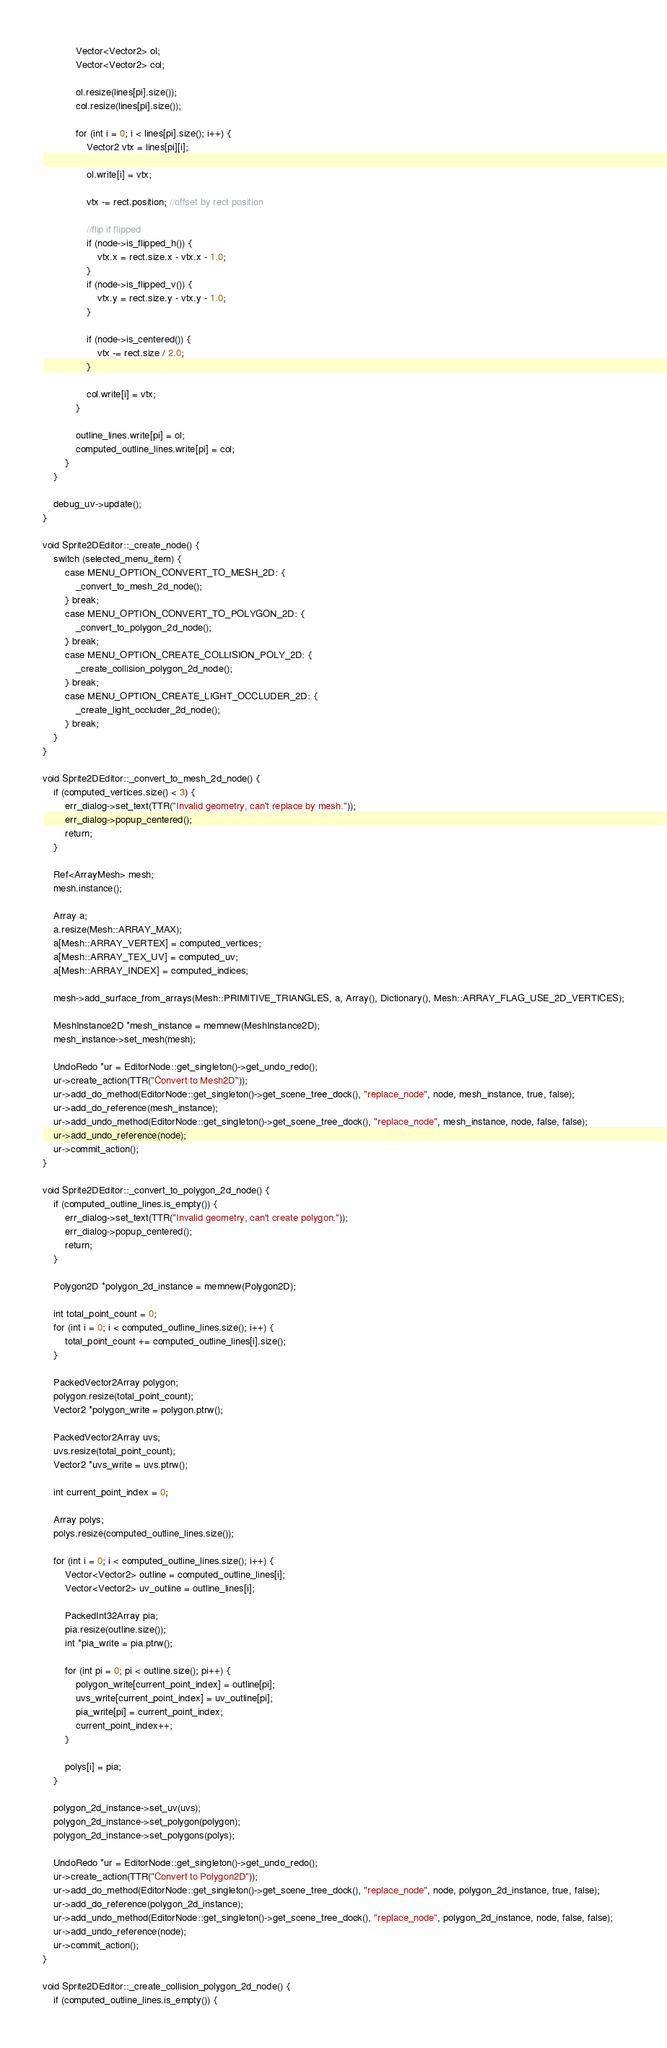<code> <loc_0><loc_0><loc_500><loc_500><_C++_>			Vector<Vector2> ol;
			Vector<Vector2> col;

			ol.resize(lines[pi].size());
			col.resize(lines[pi].size());

			for (int i = 0; i < lines[pi].size(); i++) {
				Vector2 vtx = lines[pi][i];

				ol.write[i] = vtx;

				vtx -= rect.position; //offset by rect position

				//flip if flipped
				if (node->is_flipped_h()) {
					vtx.x = rect.size.x - vtx.x - 1.0;
				}
				if (node->is_flipped_v()) {
					vtx.y = rect.size.y - vtx.y - 1.0;
				}

				if (node->is_centered()) {
					vtx -= rect.size / 2.0;
				}

				col.write[i] = vtx;
			}

			outline_lines.write[pi] = ol;
			computed_outline_lines.write[pi] = col;
		}
	}

	debug_uv->update();
}

void Sprite2DEditor::_create_node() {
	switch (selected_menu_item) {
		case MENU_OPTION_CONVERT_TO_MESH_2D: {
			_convert_to_mesh_2d_node();
		} break;
		case MENU_OPTION_CONVERT_TO_POLYGON_2D: {
			_convert_to_polygon_2d_node();
		} break;
		case MENU_OPTION_CREATE_COLLISION_POLY_2D: {
			_create_collision_polygon_2d_node();
		} break;
		case MENU_OPTION_CREATE_LIGHT_OCCLUDER_2D: {
			_create_light_occluder_2d_node();
		} break;
	}
}

void Sprite2DEditor::_convert_to_mesh_2d_node() {
	if (computed_vertices.size() < 3) {
		err_dialog->set_text(TTR("Invalid geometry, can't replace by mesh."));
		err_dialog->popup_centered();
		return;
	}

	Ref<ArrayMesh> mesh;
	mesh.instance();

	Array a;
	a.resize(Mesh::ARRAY_MAX);
	a[Mesh::ARRAY_VERTEX] = computed_vertices;
	a[Mesh::ARRAY_TEX_UV] = computed_uv;
	a[Mesh::ARRAY_INDEX] = computed_indices;

	mesh->add_surface_from_arrays(Mesh::PRIMITIVE_TRIANGLES, a, Array(), Dictionary(), Mesh::ARRAY_FLAG_USE_2D_VERTICES);

	MeshInstance2D *mesh_instance = memnew(MeshInstance2D);
	mesh_instance->set_mesh(mesh);

	UndoRedo *ur = EditorNode::get_singleton()->get_undo_redo();
	ur->create_action(TTR("Convert to Mesh2D"));
	ur->add_do_method(EditorNode::get_singleton()->get_scene_tree_dock(), "replace_node", node, mesh_instance, true, false);
	ur->add_do_reference(mesh_instance);
	ur->add_undo_method(EditorNode::get_singleton()->get_scene_tree_dock(), "replace_node", mesh_instance, node, false, false);
	ur->add_undo_reference(node);
	ur->commit_action();
}

void Sprite2DEditor::_convert_to_polygon_2d_node() {
	if (computed_outline_lines.is_empty()) {
		err_dialog->set_text(TTR("Invalid geometry, can't create polygon."));
		err_dialog->popup_centered();
		return;
	}

	Polygon2D *polygon_2d_instance = memnew(Polygon2D);

	int total_point_count = 0;
	for (int i = 0; i < computed_outline_lines.size(); i++) {
		total_point_count += computed_outline_lines[i].size();
	}

	PackedVector2Array polygon;
	polygon.resize(total_point_count);
	Vector2 *polygon_write = polygon.ptrw();

	PackedVector2Array uvs;
	uvs.resize(total_point_count);
	Vector2 *uvs_write = uvs.ptrw();

	int current_point_index = 0;

	Array polys;
	polys.resize(computed_outline_lines.size());

	for (int i = 0; i < computed_outline_lines.size(); i++) {
		Vector<Vector2> outline = computed_outline_lines[i];
		Vector<Vector2> uv_outline = outline_lines[i];

		PackedInt32Array pia;
		pia.resize(outline.size());
		int *pia_write = pia.ptrw();

		for (int pi = 0; pi < outline.size(); pi++) {
			polygon_write[current_point_index] = outline[pi];
			uvs_write[current_point_index] = uv_outline[pi];
			pia_write[pi] = current_point_index;
			current_point_index++;
		}

		polys[i] = pia;
	}

	polygon_2d_instance->set_uv(uvs);
	polygon_2d_instance->set_polygon(polygon);
	polygon_2d_instance->set_polygons(polys);

	UndoRedo *ur = EditorNode::get_singleton()->get_undo_redo();
	ur->create_action(TTR("Convert to Polygon2D"));
	ur->add_do_method(EditorNode::get_singleton()->get_scene_tree_dock(), "replace_node", node, polygon_2d_instance, true, false);
	ur->add_do_reference(polygon_2d_instance);
	ur->add_undo_method(EditorNode::get_singleton()->get_scene_tree_dock(), "replace_node", polygon_2d_instance, node, false, false);
	ur->add_undo_reference(node);
	ur->commit_action();
}

void Sprite2DEditor::_create_collision_polygon_2d_node() {
	if (computed_outline_lines.is_empty()) {</code> 